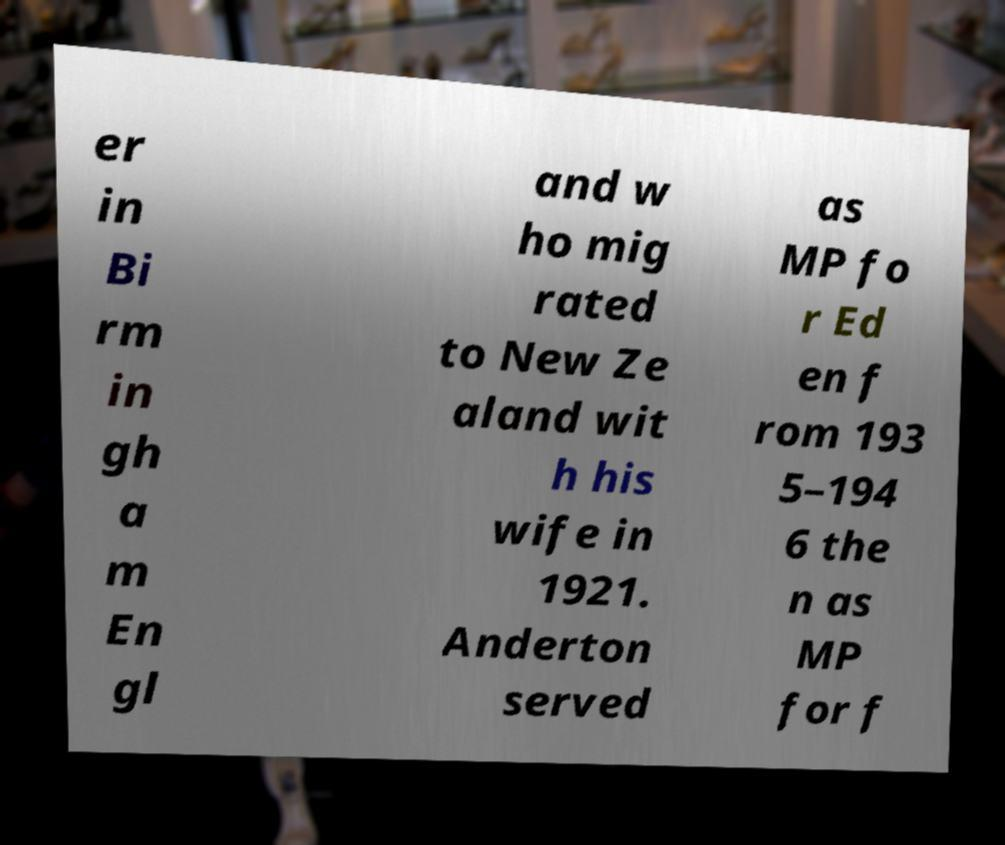Please read and relay the text visible in this image. What does it say? er in Bi rm in gh a m En gl and w ho mig rated to New Ze aland wit h his wife in 1921. Anderton served as MP fo r Ed en f rom 193 5–194 6 the n as MP for f 